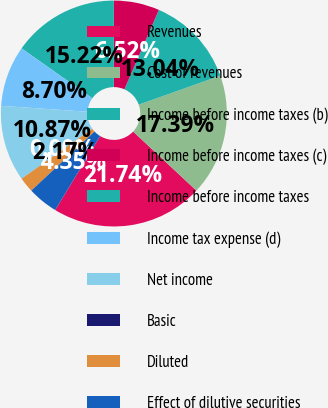Convert chart to OTSL. <chart><loc_0><loc_0><loc_500><loc_500><pie_chart><fcel>Revenues<fcel>Cost of revenues<fcel>Income before income taxes (b)<fcel>Income before income taxes (c)<fcel>Income before income taxes<fcel>Income tax expense (d)<fcel>Net income<fcel>Basic<fcel>Diluted<fcel>Effect of dilutive securities<nl><fcel>21.74%<fcel>17.39%<fcel>13.04%<fcel>6.52%<fcel>15.22%<fcel>8.7%<fcel>10.87%<fcel>0.0%<fcel>2.17%<fcel>4.35%<nl></chart> 